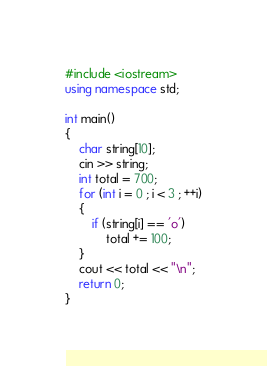<code> <loc_0><loc_0><loc_500><loc_500><_C++_>#include <iostream>
using namespace std;

int main()
{
	char string[10];
	cin >> string;
	int total = 700;
	for (int i = 0 ; i < 3 ; ++i)
	{
		if (string[i] == 'o')
			total += 100;
	}
	cout << total << "\n";
	return 0;
}</code> 